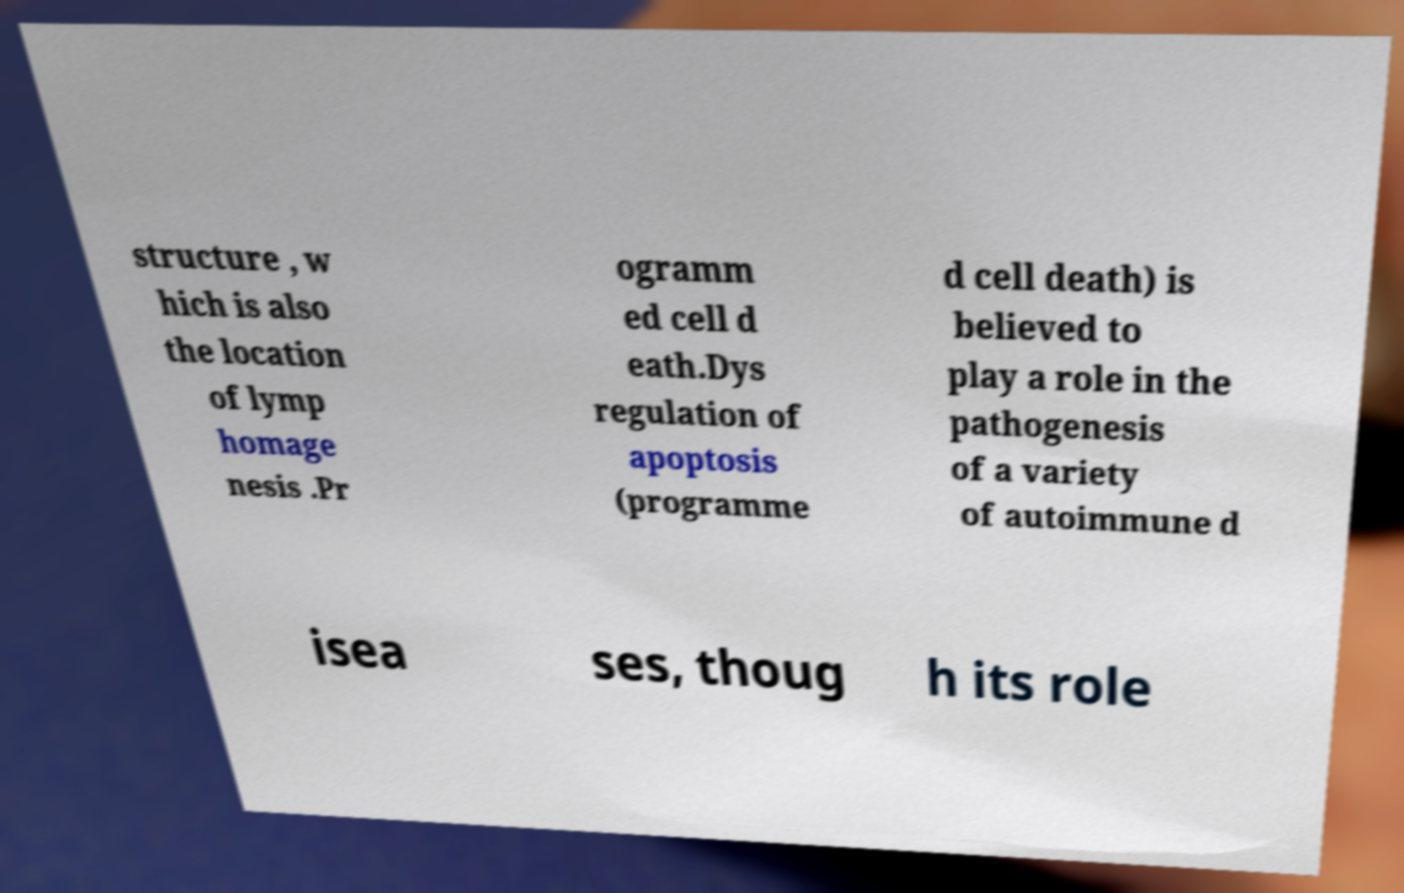I need the written content from this picture converted into text. Can you do that? structure , w hich is also the location of lymp homage nesis .Pr ogramm ed cell d eath.Dys regulation of apoptosis (programme d cell death) is believed to play a role in the pathogenesis of a variety of autoimmune d isea ses, thoug h its role 